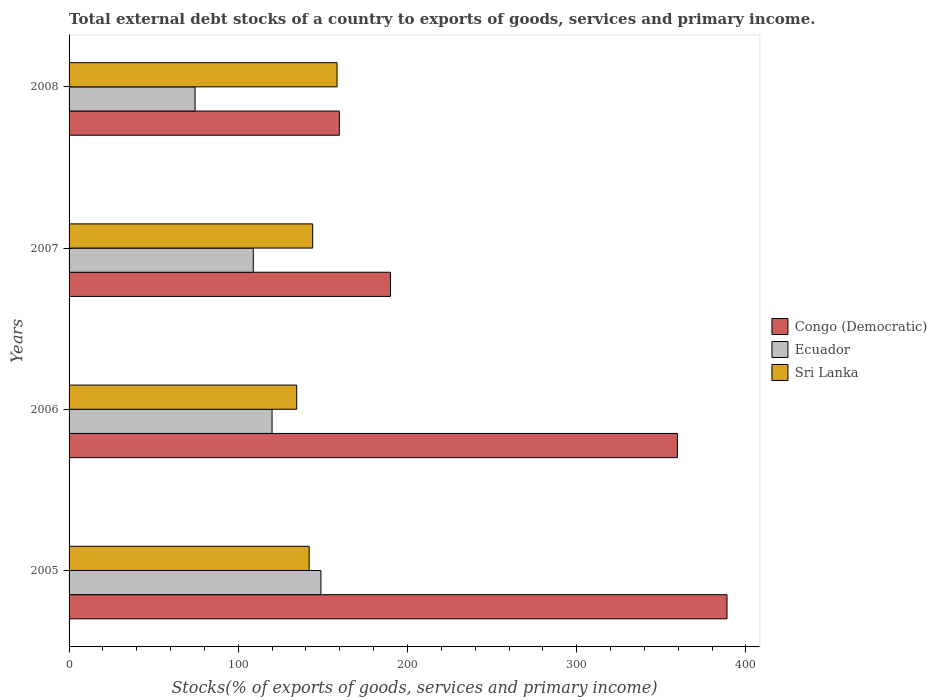How many different coloured bars are there?
Make the answer very short. 3. How many groups of bars are there?
Provide a short and direct response. 4. Are the number of bars on each tick of the Y-axis equal?
Keep it short and to the point. Yes. What is the label of the 3rd group of bars from the top?
Your response must be concise. 2006. In how many cases, is the number of bars for a given year not equal to the number of legend labels?
Make the answer very short. 0. What is the total debt stocks in Sri Lanka in 2008?
Make the answer very short. 158.36. Across all years, what is the maximum total debt stocks in Ecuador?
Your answer should be very brief. 148.83. Across all years, what is the minimum total debt stocks in Congo (Democratic)?
Provide a succinct answer. 159.7. In which year was the total debt stocks in Ecuador maximum?
Provide a succinct answer. 2005. In which year was the total debt stocks in Ecuador minimum?
Offer a very short reply. 2008. What is the total total debt stocks in Ecuador in the graph?
Provide a short and direct response. 452.12. What is the difference between the total debt stocks in Ecuador in 2005 and that in 2008?
Provide a succinct answer. 74.36. What is the difference between the total debt stocks in Ecuador in 2008 and the total debt stocks in Congo (Democratic) in 2007?
Offer a terse response. -115.47. What is the average total debt stocks in Ecuador per year?
Your answer should be compact. 113.03. In the year 2006, what is the difference between the total debt stocks in Ecuador and total debt stocks in Sri Lanka?
Provide a short and direct response. -14.57. What is the ratio of the total debt stocks in Congo (Democratic) in 2005 to that in 2006?
Provide a succinct answer. 1.08. Is the total debt stocks in Sri Lanka in 2005 less than that in 2008?
Ensure brevity in your answer.  Yes. What is the difference between the highest and the second highest total debt stocks in Sri Lanka?
Make the answer very short. 14.39. What is the difference between the highest and the lowest total debt stocks in Sri Lanka?
Your response must be concise. 23.83. In how many years, is the total debt stocks in Congo (Democratic) greater than the average total debt stocks in Congo (Democratic) taken over all years?
Your answer should be compact. 2. What does the 1st bar from the top in 2008 represents?
Your answer should be very brief. Sri Lanka. What does the 2nd bar from the bottom in 2008 represents?
Offer a terse response. Ecuador. Are all the bars in the graph horizontal?
Offer a terse response. Yes. How many years are there in the graph?
Your response must be concise. 4. What is the difference between two consecutive major ticks on the X-axis?
Ensure brevity in your answer.  100. Does the graph contain any zero values?
Give a very brief answer. No. Does the graph contain grids?
Offer a very short reply. No. Where does the legend appear in the graph?
Keep it short and to the point. Center right. How many legend labels are there?
Provide a succinct answer. 3. How are the legend labels stacked?
Offer a terse response. Vertical. What is the title of the graph?
Offer a terse response. Total external debt stocks of a country to exports of goods, services and primary income. What is the label or title of the X-axis?
Keep it short and to the point. Stocks(% of exports of goods, services and primary income). What is the label or title of the Y-axis?
Ensure brevity in your answer.  Years. What is the Stocks(% of exports of goods, services and primary income) of Congo (Democratic) in 2005?
Your answer should be compact. 388.81. What is the Stocks(% of exports of goods, services and primary income) of Ecuador in 2005?
Offer a very short reply. 148.83. What is the Stocks(% of exports of goods, services and primary income) in Sri Lanka in 2005?
Your answer should be very brief. 141.88. What is the Stocks(% of exports of goods, services and primary income) in Congo (Democratic) in 2006?
Your response must be concise. 359.49. What is the Stocks(% of exports of goods, services and primary income) in Ecuador in 2006?
Ensure brevity in your answer.  119.96. What is the Stocks(% of exports of goods, services and primary income) in Sri Lanka in 2006?
Offer a terse response. 134.53. What is the Stocks(% of exports of goods, services and primary income) in Congo (Democratic) in 2007?
Your answer should be very brief. 189.94. What is the Stocks(% of exports of goods, services and primary income) in Ecuador in 2007?
Ensure brevity in your answer.  108.87. What is the Stocks(% of exports of goods, services and primary income) in Sri Lanka in 2007?
Give a very brief answer. 143.97. What is the Stocks(% of exports of goods, services and primary income) in Congo (Democratic) in 2008?
Ensure brevity in your answer.  159.7. What is the Stocks(% of exports of goods, services and primary income) in Ecuador in 2008?
Your response must be concise. 74.46. What is the Stocks(% of exports of goods, services and primary income) of Sri Lanka in 2008?
Your answer should be compact. 158.36. Across all years, what is the maximum Stocks(% of exports of goods, services and primary income) in Congo (Democratic)?
Offer a terse response. 388.81. Across all years, what is the maximum Stocks(% of exports of goods, services and primary income) in Ecuador?
Give a very brief answer. 148.83. Across all years, what is the maximum Stocks(% of exports of goods, services and primary income) in Sri Lanka?
Your answer should be compact. 158.36. Across all years, what is the minimum Stocks(% of exports of goods, services and primary income) of Congo (Democratic)?
Your answer should be compact. 159.7. Across all years, what is the minimum Stocks(% of exports of goods, services and primary income) in Ecuador?
Ensure brevity in your answer.  74.46. Across all years, what is the minimum Stocks(% of exports of goods, services and primary income) of Sri Lanka?
Give a very brief answer. 134.53. What is the total Stocks(% of exports of goods, services and primary income) in Congo (Democratic) in the graph?
Ensure brevity in your answer.  1097.94. What is the total Stocks(% of exports of goods, services and primary income) in Ecuador in the graph?
Ensure brevity in your answer.  452.12. What is the total Stocks(% of exports of goods, services and primary income) in Sri Lanka in the graph?
Give a very brief answer. 578.75. What is the difference between the Stocks(% of exports of goods, services and primary income) in Congo (Democratic) in 2005 and that in 2006?
Provide a short and direct response. 29.32. What is the difference between the Stocks(% of exports of goods, services and primary income) of Ecuador in 2005 and that in 2006?
Keep it short and to the point. 28.87. What is the difference between the Stocks(% of exports of goods, services and primary income) in Sri Lanka in 2005 and that in 2006?
Offer a very short reply. 7.35. What is the difference between the Stocks(% of exports of goods, services and primary income) in Congo (Democratic) in 2005 and that in 2007?
Ensure brevity in your answer.  198.88. What is the difference between the Stocks(% of exports of goods, services and primary income) of Ecuador in 2005 and that in 2007?
Offer a terse response. 39.95. What is the difference between the Stocks(% of exports of goods, services and primary income) of Sri Lanka in 2005 and that in 2007?
Offer a very short reply. -2.1. What is the difference between the Stocks(% of exports of goods, services and primary income) in Congo (Democratic) in 2005 and that in 2008?
Provide a succinct answer. 229.11. What is the difference between the Stocks(% of exports of goods, services and primary income) of Ecuador in 2005 and that in 2008?
Your response must be concise. 74.36. What is the difference between the Stocks(% of exports of goods, services and primary income) in Sri Lanka in 2005 and that in 2008?
Keep it short and to the point. -16.48. What is the difference between the Stocks(% of exports of goods, services and primary income) in Congo (Democratic) in 2006 and that in 2007?
Your answer should be compact. 169.55. What is the difference between the Stocks(% of exports of goods, services and primary income) in Ecuador in 2006 and that in 2007?
Give a very brief answer. 11.09. What is the difference between the Stocks(% of exports of goods, services and primary income) of Sri Lanka in 2006 and that in 2007?
Your answer should be compact. -9.44. What is the difference between the Stocks(% of exports of goods, services and primary income) in Congo (Democratic) in 2006 and that in 2008?
Your response must be concise. 199.79. What is the difference between the Stocks(% of exports of goods, services and primary income) in Ecuador in 2006 and that in 2008?
Ensure brevity in your answer.  45.5. What is the difference between the Stocks(% of exports of goods, services and primary income) in Sri Lanka in 2006 and that in 2008?
Your response must be concise. -23.83. What is the difference between the Stocks(% of exports of goods, services and primary income) of Congo (Democratic) in 2007 and that in 2008?
Provide a short and direct response. 30.23. What is the difference between the Stocks(% of exports of goods, services and primary income) in Ecuador in 2007 and that in 2008?
Your answer should be very brief. 34.41. What is the difference between the Stocks(% of exports of goods, services and primary income) in Sri Lanka in 2007 and that in 2008?
Provide a succinct answer. -14.39. What is the difference between the Stocks(% of exports of goods, services and primary income) of Congo (Democratic) in 2005 and the Stocks(% of exports of goods, services and primary income) of Ecuador in 2006?
Provide a succinct answer. 268.85. What is the difference between the Stocks(% of exports of goods, services and primary income) of Congo (Democratic) in 2005 and the Stocks(% of exports of goods, services and primary income) of Sri Lanka in 2006?
Provide a short and direct response. 254.28. What is the difference between the Stocks(% of exports of goods, services and primary income) of Ecuador in 2005 and the Stocks(% of exports of goods, services and primary income) of Sri Lanka in 2006?
Your answer should be very brief. 14.29. What is the difference between the Stocks(% of exports of goods, services and primary income) of Congo (Democratic) in 2005 and the Stocks(% of exports of goods, services and primary income) of Ecuador in 2007?
Your answer should be very brief. 279.94. What is the difference between the Stocks(% of exports of goods, services and primary income) of Congo (Democratic) in 2005 and the Stocks(% of exports of goods, services and primary income) of Sri Lanka in 2007?
Give a very brief answer. 244.84. What is the difference between the Stocks(% of exports of goods, services and primary income) of Ecuador in 2005 and the Stocks(% of exports of goods, services and primary income) of Sri Lanka in 2007?
Ensure brevity in your answer.  4.85. What is the difference between the Stocks(% of exports of goods, services and primary income) in Congo (Democratic) in 2005 and the Stocks(% of exports of goods, services and primary income) in Ecuador in 2008?
Offer a very short reply. 314.35. What is the difference between the Stocks(% of exports of goods, services and primary income) in Congo (Democratic) in 2005 and the Stocks(% of exports of goods, services and primary income) in Sri Lanka in 2008?
Provide a succinct answer. 230.45. What is the difference between the Stocks(% of exports of goods, services and primary income) of Ecuador in 2005 and the Stocks(% of exports of goods, services and primary income) of Sri Lanka in 2008?
Ensure brevity in your answer.  -9.54. What is the difference between the Stocks(% of exports of goods, services and primary income) in Congo (Democratic) in 2006 and the Stocks(% of exports of goods, services and primary income) in Ecuador in 2007?
Your response must be concise. 250.62. What is the difference between the Stocks(% of exports of goods, services and primary income) of Congo (Democratic) in 2006 and the Stocks(% of exports of goods, services and primary income) of Sri Lanka in 2007?
Ensure brevity in your answer.  215.51. What is the difference between the Stocks(% of exports of goods, services and primary income) in Ecuador in 2006 and the Stocks(% of exports of goods, services and primary income) in Sri Lanka in 2007?
Your answer should be compact. -24.01. What is the difference between the Stocks(% of exports of goods, services and primary income) in Congo (Democratic) in 2006 and the Stocks(% of exports of goods, services and primary income) in Ecuador in 2008?
Make the answer very short. 285.02. What is the difference between the Stocks(% of exports of goods, services and primary income) of Congo (Democratic) in 2006 and the Stocks(% of exports of goods, services and primary income) of Sri Lanka in 2008?
Provide a succinct answer. 201.12. What is the difference between the Stocks(% of exports of goods, services and primary income) of Ecuador in 2006 and the Stocks(% of exports of goods, services and primary income) of Sri Lanka in 2008?
Offer a terse response. -38.4. What is the difference between the Stocks(% of exports of goods, services and primary income) of Congo (Democratic) in 2007 and the Stocks(% of exports of goods, services and primary income) of Ecuador in 2008?
Give a very brief answer. 115.47. What is the difference between the Stocks(% of exports of goods, services and primary income) of Congo (Democratic) in 2007 and the Stocks(% of exports of goods, services and primary income) of Sri Lanka in 2008?
Keep it short and to the point. 31.57. What is the difference between the Stocks(% of exports of goods, services and primary income) of Ecuador in 2007 and the Stocks(% of exports of goods, services and primary income) of Sri Lanka in 2008?
Provide a short and direct response. -49.49. What is the average Stocks(% of exports of goods, services and primary income) in Congo (Democratic) per year?
Offer a very short reply. 274.48. What is the average Stocks(% of exports of goods, services and primary income) of Ecuador per year?
Make the answer very short. 113.03. What is the average Stocks(% of exports of goods, services and primary income) of Sri Lanka per year?
Ensure brevity in your answer.  144.69. In the year 2005, what is the difference between the Stocks(% of exports of goods, services and primary income) in Congo (Democratic) and Stocks(% of exports of goods, services and primary income) in Ecuador?
Give a very brief answer. 239.99. In the year 2005, what is the difference between the Stocks(% of exports of goods, services and primary income) of Congo (Democratic) and Stocks(% of exports of goods, services and primary income) of Sri Lanka?
Ensure brevity in your answer.  246.93. In the year 2005, what is the difference between the Stocks(% of exports of goods, services and primary income) of Ecuador and Stocks(% of exports of goods, services and primary income) of Sri Lanka?
Your response must be concise. 6.95. In the year 2006, what is the difference between the Stocks(% of exports of goods, services and primary income) in Congo (Democratic) and Stocks(% of exports of goods, services and primary income) in Ecuador?
Give a very brief answer. 239.53. In the year 2006, what is the difference between the Stocks(% of exports of goods, services and primary income) of Congo (Democratic) and Stocks(% of exports of goods, services and primary income) of Sri Lanka?
Offer a very short reply. 224.95. In the year 2006, what is the difference between the Stocks(% of exports of goods, services and primary income) in Ecuador and Stocks(% of exports of goods, services and primary income) in Sri Lanka?
Keep it short and to the point. -14.57. In the year 2007, what is the difference between the Stocks(% of exports of goods, services and primary income) in Congo (Democratic) and Stocks(% of exports of goods, services and primary income) in Ecuador?
Provide a short and direct response. 81.06. In the year 2007, what is the difference between the Stocks(% of exports of goods, services and primary income) in Congo (Democratic) and Stocks(% of exports of goods, services and primary income) in Sri Lanka?
Keep it short and to the point. 45.96. In the year 2007, what is the difference between the Stocks(% of exports of goods, services and primary income) of Ecuador and Stocks(% of exports of goods, services and primary income) of Sri Lanka?
Your response must be concise. -35.1. In the year 2008, what is the difference between the Stocks(% of exports of goods, services and primary income) in Congo (Democratic) and Stocks(% of exports of goods, services and primary income) in Ecuador?
Make the answer very short. 85.24. In the year 2008, what is the difference between the Stocks(% of exports of goods, services and primary income) in Congo (Democratic) and Stocks(% of exports of goods, services and primary income) in Sri Lanka?
Your answer should be compact. 1.34. In the year 2008, what is the difference between the Stocks(% of exports of goods, services and primary income) of Ecuador and Stocks(% of exports of goods, services and primary income) of Sri Lanka?
Offer a very short reply. -83.9. What is the ratio of the Stocks(% of exports of goods, services and primary income) of Congo (Democratic) in 2005 to that in 2006?
Give a very brief answer. 1.08. What is the ratio of the Stocks(% of exports of goods, services and primary income) of Ecuador in 2005 to that in 2006?
Give a very brief answer. 1.24. What is the ratio of the Stocks(% of exports of goods, services and primary income) of Sri Lanka in 2005 to that in 2006?
Your answer should be compact. 1.05. What is the ratio of the Stocks(% of exports of goods, services and primary income) in Congo (Democratic) in 2005 to that in 2007?
Your response must be concise. 2.05. What is the ratio of the Stocks(% of exports of goods, services and primary income) in Ecuador in 2005 to that in 2007?
Your response must be concise. 1.37. What is the ratio of the Stocks(% of exports of goods, services and primary income) of Sri Lanka in 2005 to that in 2007?
Keep it short and to the point. 0.99. What is the ratio of the Stocks(% of exports of goods, services and primary income) in Congo (Democratic) in 2005 to that in 2008?
Make the answer very short. 2.43. What is the ratio of the Stocks(% of exports of goods, services and primary income) in Ecuador in 2005 to that in 2008?
Your answer should be very brief. 2. What is the ratio of the Stocks(% of exports of goods, services and primary income) in Sri Lanka in 2005 to that in 2008?
Ensure brevity in your answer.  0.9. What is the ratio of the Stocks(% of exports of goods, services and primary income) of Congo (Democratic) in 2006 to that in 2007?
Your answer should be very brief. 1.89. What is the ratio of the Stocks(% of exports of goods, services and primary income) of Ecuador in 2006 to that in 2007?
Your answer should be very brief. 1.1. What is the ratio of the Stocks(% of exports of goods, services and primary income) in Sri Lanka in 2006 to that in 2007?
Your response must be concise. 0.93. What is the ratio of the Stocks(% of exports of goods, services and primary income) of Congo (Democratic) in 2006 to that in 2008?
Your answer should be compact. 2.25. What is the ratio of the Stocks(% of exports of goods, services and primary income) of Ecuador in 2006 to that in 2008?
Offer a very short reply. 1.61. What is the ratio of the Stocks(% of exports of goods, services and primary income) in Sri Lanka in 2006 to that in 2008?
Make the answer very short. 0.85. What is the ratio of the Stocks(% of exports of goods, services and primary income) of Congo (Democratic) in 2007 to that in 2008?
Offer a very short reply. 1.19. What is the ratio of the Stocks(% of exports of goods, services and primary income) of Ecuador in 2007 to that in 2008?
Offer a very short reply. 1.46. What is the ratio of the Stocks(% of exports of goods, services and primary income) of Sri Lanka in 2007 to that in 2008?
Give a very brief answer. 0.91. What is the difference between the highest and the second highest Stocks(% of exports of goods, services and primary income) of Congo (Democratic)?
Provide a short and direct response. 29.32. What is the difference between the highest and the second highest Stocks(% of exports of goods, services and primary income) in Ecuador?
Give a very brief answer. 28.87. What is the difference between the highest and the second highest Stocks(% of exports of goods, services and primary income) in Sri Lanka?
Offer a terse response. 14.39. What is the difference between the highest and the lowest Stocks(% of exports of goods, services and primary income) in Congo (Democratic)?
Give a very brief answer. 229.11. What is the difference between the highest and the lowest Stocks(% of exports of goods, services and primary income) of Ecuador?
Offer a terse response. 74.36. What is the difference between the highest and the lowest Stocks(% of exports of goods, services and primary income) in Sri Lanka?
Provide a short and direct response. 23.83. 